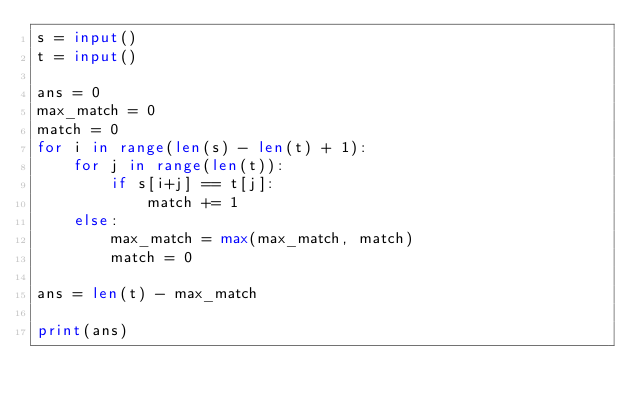Convert code to text. <code><loc_0><loc_0><loc_500><loc_500><_Python_>s = input()
t = input()

ans = 0
max_match = 0
match = 0
for i in range(len(s) - len(t) + 1):
    for j in range(len(t)):
        if s[i+j] == t[j]:
            match += 1
    else:
        max_match = max(max_match, match)
        match = 0

ans = len(t) - max_match

print(ans)

</code> 